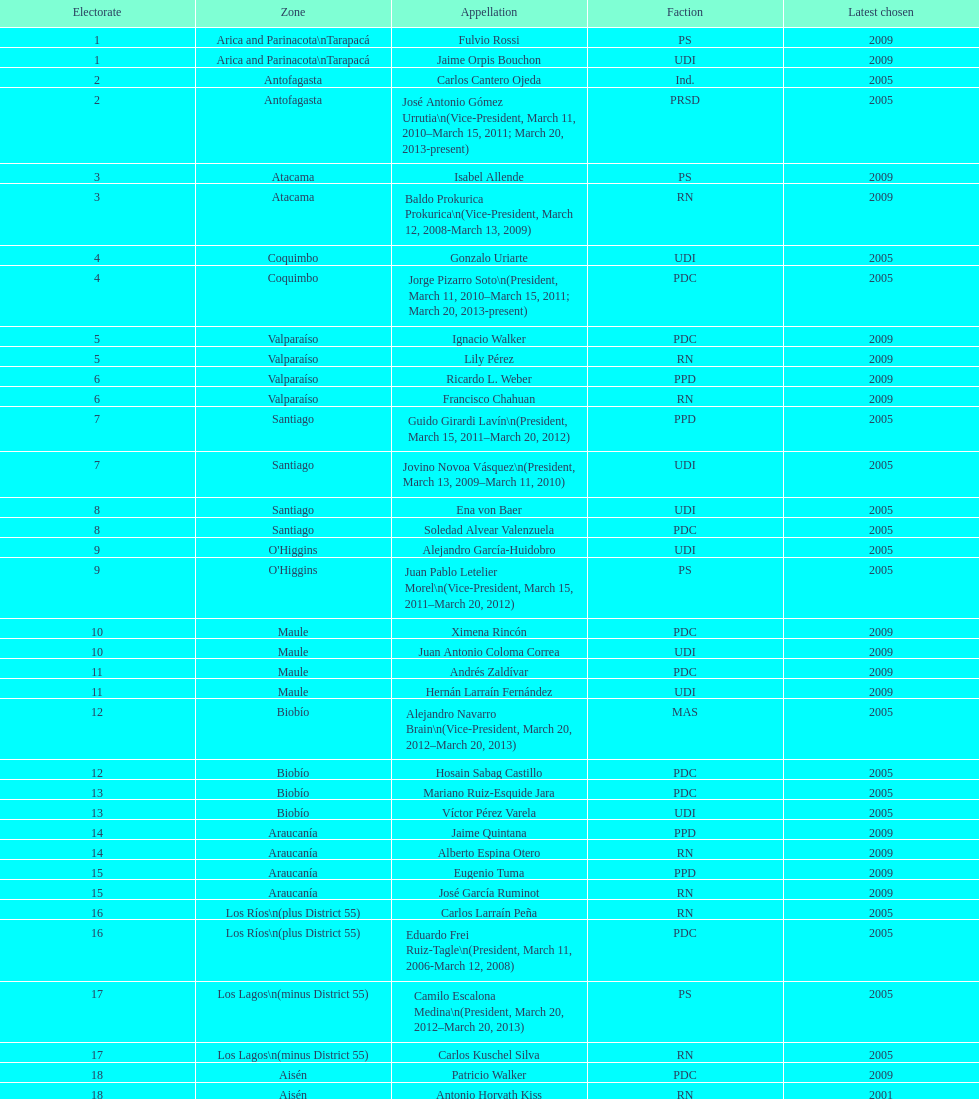Which party did jaime quintana belong to? PPD. Give me the full table as a dictionary. {'header': ['Electorate', 'Zone', 'Appellation', 'Faction', 'Latest chosen'], 'rows': [['1', 'Arica and Parinacota\\nTarapacá', 'Fulvio Rossi', 'PS', '2009'], ['1', 'Arica and Parinacota\\nTarapacá', 'Jaime Orpis Bouchon', 'UDI', '2009'], ['2', 'Antofagasta', 'Carlos Cantero Ojeda', 'Ind.', '2005'], ['2', 'Antofagasta', 'José Antonio Gómez Urrutia\\n(Vice-President, March 11, 2010–March 15, 2011; March 20, 2013-present)', 'PRSD', '2005'], ['3', 'Atacama', 'Isabel Allende', 'PS', '2009'], ['3', 'Atacama', 'Baldo Prokurica Prokurica\\n(Vice-President, March 12, 2008-March 13, 2009)', 'RN', '2009'], ['4', 'Coquimbo', 'Gonzalo Uriarte', 'UDI', '2005'], ['4', 'Coquimbo', 'Jorge Pizarro Soto\\n(President, March 11, 2010–March 15, 2011; March 20, 2013-present)', 'PDC', '2005'], ['5', 'Valparaíso', 'Ignacio Walker', 'PDC', '2009'], ['5', 'Valparaíso', 'Lily Pérez', 'RN', '2009'], ['6', 'Valparaíso', 'Ricardo L. Weber', 'PPD', '2009'], ['6', 'Valparaíso', 'Francisco Chahuan', 'RN', '2009'], ['7', 'Santiago', 'Guido Girardi Lavín\\n(President, March 15, 2011–March 20, 2012)', 'PPD', '2005'], ['7', 'Santiago', 'Jovino Novoa Vásquez\\n(President, March 13, 2009–March 11, 2010)', 'UDI', '2005'], ['8', 'Santiago', 'Ena von Baer', 'UDI', '2005'], ['8', 'Santiago', 'Soledad Alvear Valenzuela', 'PDC', '2005'], ['9', "O'Higgins", 'Alejandro García-Huidobro', 'UDI', '2005'], ['9', "O'Higgins", 'Juan Pablo Letelier Morel\\n(Vice-President, March 15, 2011–March 20, 2012)', 'PS', '2005'], ['10', 'Maule', 'Ximena Rincón', 'PDC', '2009'], ['10', 'Maule', 'Juan Antonio Coloma Correa', 'UDI', '2009'], ['11', 'Maule', 'Andrés Zaldívar', 'PDC', '2009'], ['11', 'Maule', 'Hernán Larraín Fernández', 'UDI', '2009'], ['12', 'Biobío', 'Alejandro Navarro Brain\\n(Vice-President, March 20, 2012–March 20, 2013)', 'MAS', '2005'], ['12', 'Biobío', 'Hosain Sabag Castillo', 'PDC', '2005'], ['13', 'Biobío', 'Mariano Ruiz-Esquide Jara', 'PDC', '2005'], ['13', 'Biobío', 'Víctor Pérez Varela', 'UDI', '2005'], ['14', 'Araucanía', 'Jaime Quintana', 'PPD', '2009'], ['14', 'Araucanía', 'Alberto Espina Otero', 'RN', '2009'], ['15', 'Araucanía', 'Eugenio Tuma', 'PPD', '2009'], ['15', 'Araucanía', 'José García Ruminot', 'RN', '2009'], ['16', 'Los Ríos\\n(plus District 55)', 'Carlos Larraín Peña', 'RN', '2005'], ['16', 'Los Ríos\\n(plus District 55)', 'Eduardo Frei Ruiz-Tagle\\n(President, March 11, 2006-March 12, 2008)', 'PDC', '2005'], ['17', 'Los Lagos\\n(minus District 55)', 'Camilo Escalona Medina\\n(President, March 20, 2012–March 20, 2013)', 'PS', '2005'], ['17', 'Los Lagos\\n(minus District 55)', 'Carlos Kuschel Silva', 'RN', '2005'], ['18', 'Aisén', 'Patricio Walker', 'PDC', '2009'], ['18', 'Aisén', 'Antonio Horvath Kiss', 'RN', '2001'], ['19', 'Magallanes', 'Carlos Bianchi Chelech\\n(Vice-President, March 13, 2009–March 11, 2010)', 'Ind.', '2005'], ['19', 'Magallanes', 'Pedro Muñoz Aburto', 'PS', '2005']]} 